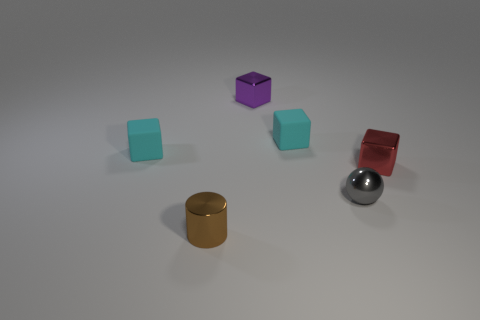Is the tiny brown thing that is in front of the red block made of the same material as the small cube that is to the right of the tiny gray sphere?
Make the answer very short. Yes. What number of other things are there of the same color as the tiny cylinder?
Make the answer very short. 0. What number of things are small things that are behind the red shiny block or tiny things in front of the red metallic cube?
Ensure brevity in your answer.  5. There is a brown cylinder in front of the cyan object to the left of the tiny purple shiny object; what is its size?
Offer a terse response. Small. Does the thing that is to the left of the tiny brown cylinder have the same color as the rubber cube that is to the right of the purple metal block?
Provide a short and direct response. Yes. What number of other things are there of the same material as the red thing
Ensure brevity in your answer.  3. Are any large matte things visible?
Provide a short and direct response. No. Are the cylinder on the left side of the purple shiny object and the small red thing made of the same material?
Your answer should be very brief. Yes. There is a red object that is the same shape as the small purple metal object; what material is it?
Offer a terse response. Metal. Is the number of big red matte cylinders less than the number of tiny brown cylinders?
Ensure brevity in your answer.  Yes. 